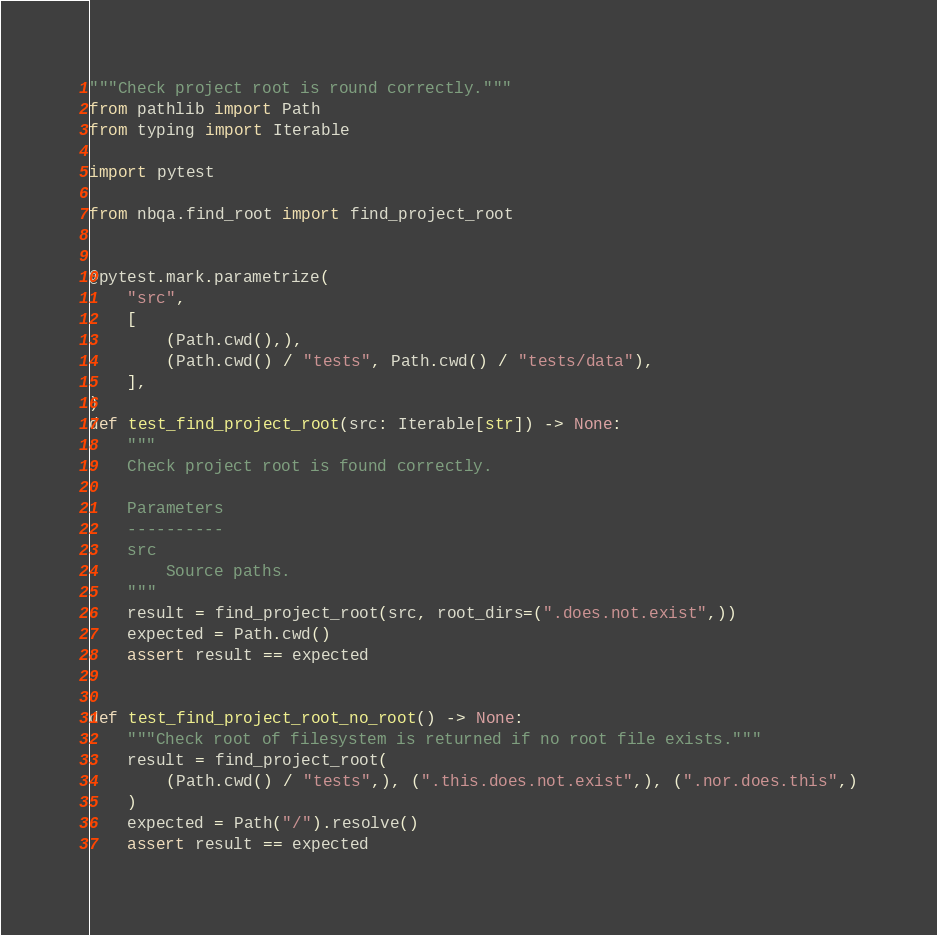Convert code to text. <code><loc_0><loc_0><loc_500><loc_500><_Python_>"""Check project root is round correctly."""
from pathlib import Path
from typing import Iterable

import pytest

from nbqa.find_root import find_project_root


@pytest.mark.parametrize(
    "src",
    [
        (Path.cwd(),),
        (Path.cwd() / "tests", Path.cwd() / "tests/data"),
    ],
)
def test_find_project_root(src: Iterable[str]) -> None:
    """
    Check project root is found correctly.

    Parameters
    ----------
    src
        Source paths.
    """
    result = find_project_root(src, root_dirs=(".does.not.exist",))
    expected = Path.cwd()
    assert result == expected


def test_find_project_root_no_root() -> None:
    """Check root of filesystem is returned if no root file exists."""
    result = find_project_root(
        (Path.cwd() / "tests",), (".this.does.not.exist",), (".nor.does.this",)
    )
    expected = Path("/").resolve()
    assert result == expected
</code> 